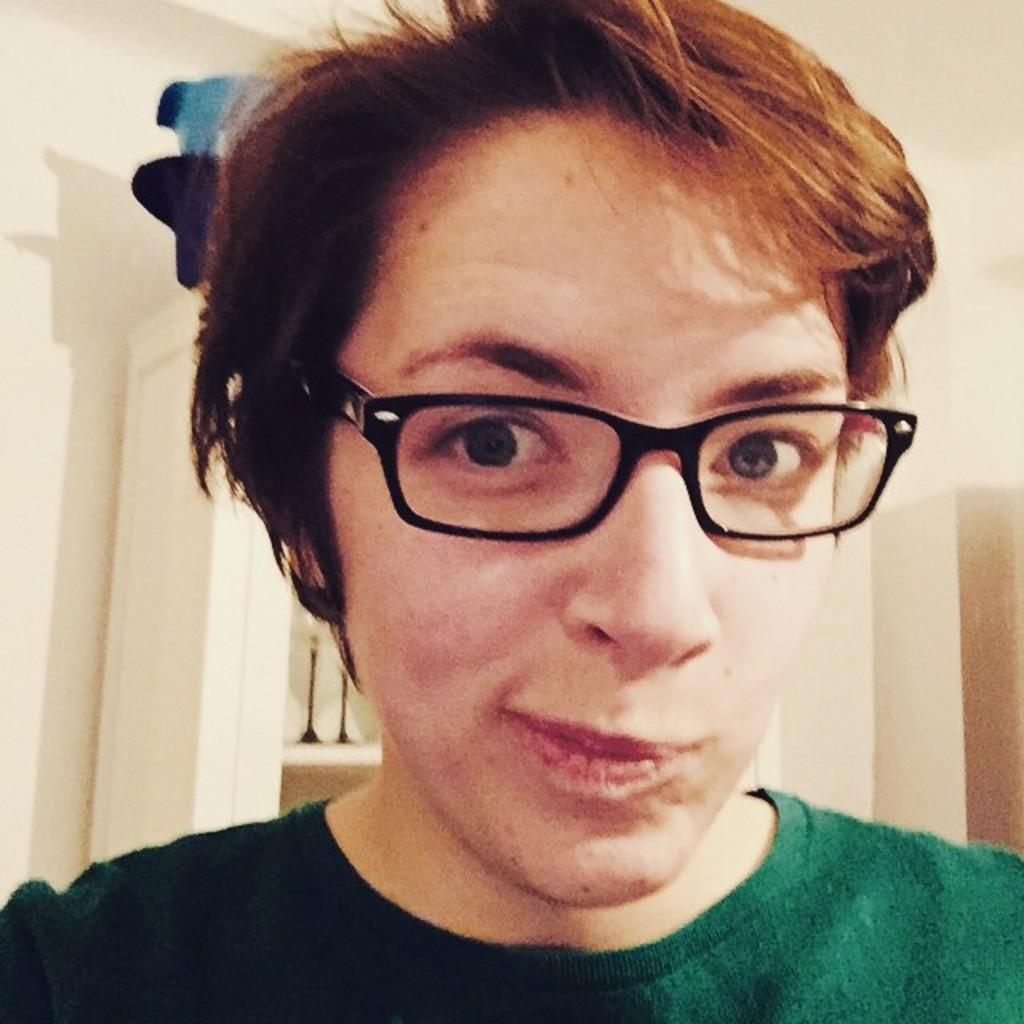Who is present in the image? There is a man in the image. What accessory is the man wearing? The man is wearing glasses. What can be seen in the background of the image? There is a wall in the background of the image. How many birds are in the flock that is visible in the image? There is no flock of birds present in the image; it features a man wearing glasses with a wall in the background. 